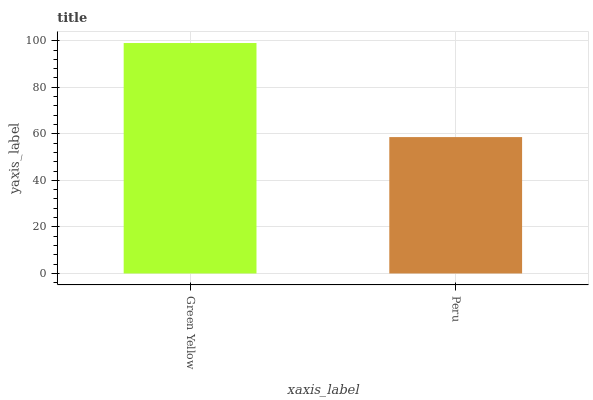Is Peru the minimum?
Answer yes or no. Yes. Is Green Yellow the maximum?
Answer yes or no. Yes. Is Peru the maximum?
Answer yes or no. No. Is Green Yellow greater than Peru?
Answer yes or no. Yes. Is Peru less than Green Yellow?
Answer yes or no. Yes. Is Peru greater than Green Yellow?
Answer yes or no. No. Is Green Yellow less than Peru?
Answer yes or no. No. Is Green Yellow the high median?
Answer yes or no. Yes. Is Peru the low median?
Answer yes or no. Yes. Is Peru the high median?
Answer yes or no. No. Is Green Yellow the low median?
Answer yes or no. No. 